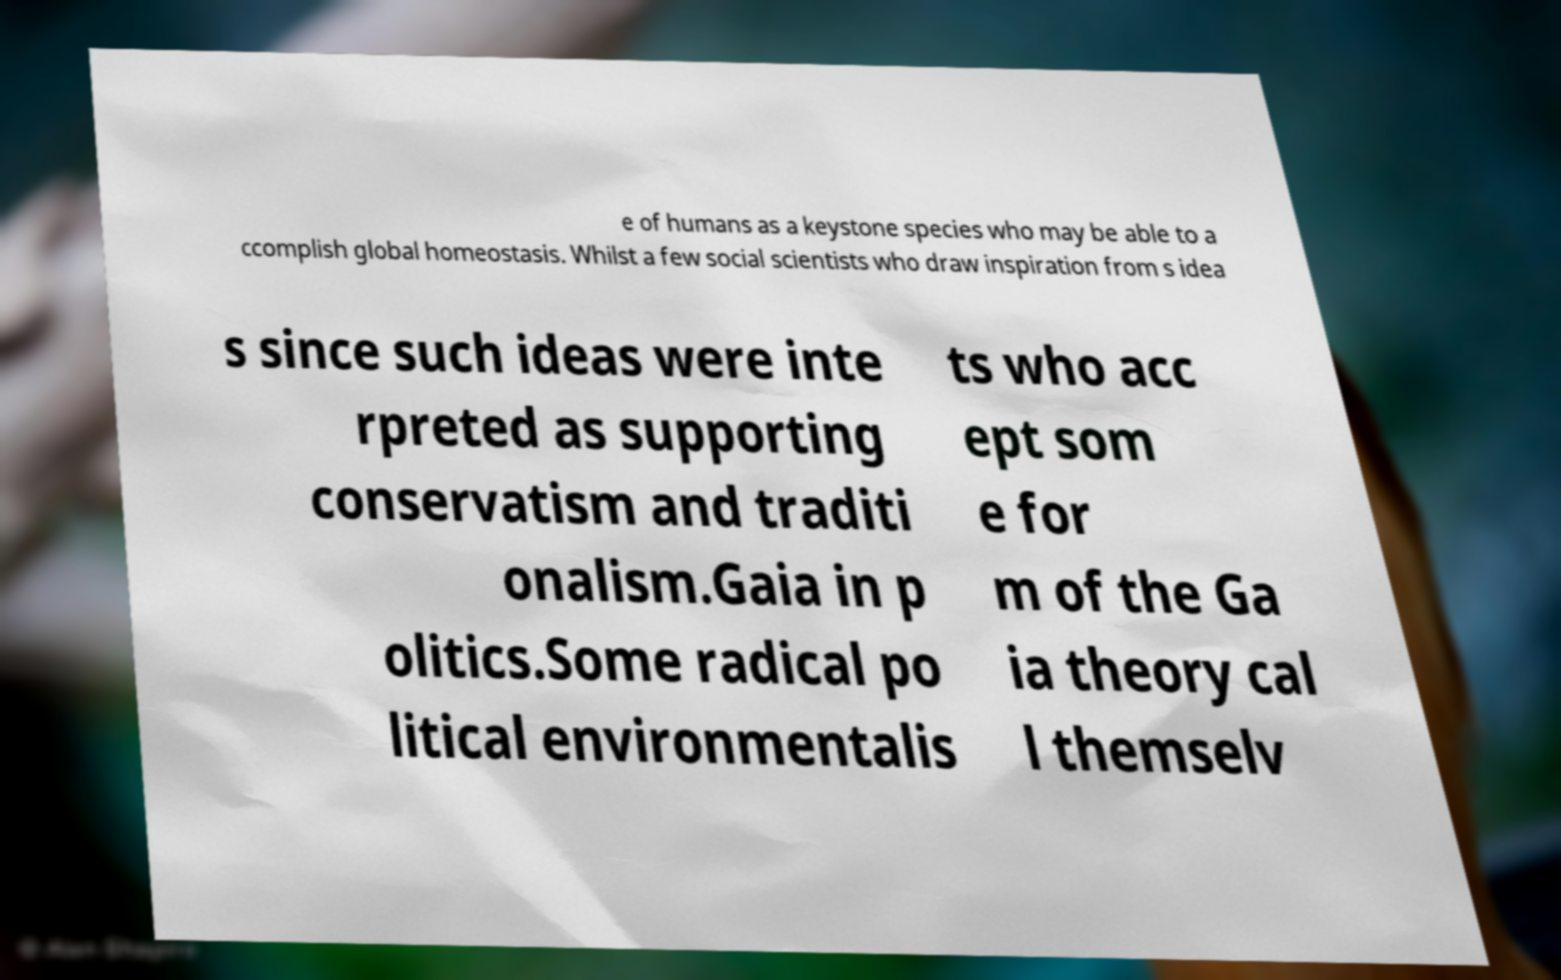Please read and relay the text visible in this image. What does it say? e of humans as a keystone species who may be able to a ccomplish global homeostasis. Whilst a few social scientists who draw inspiration from s idea s since such ideas were inte rpreted as supporting conservatism and traditi onalism.Gaia in p olitics.Some radical po litical environmentalis ts who acc ept som e for m of the Ga ia theory cal l themselv 